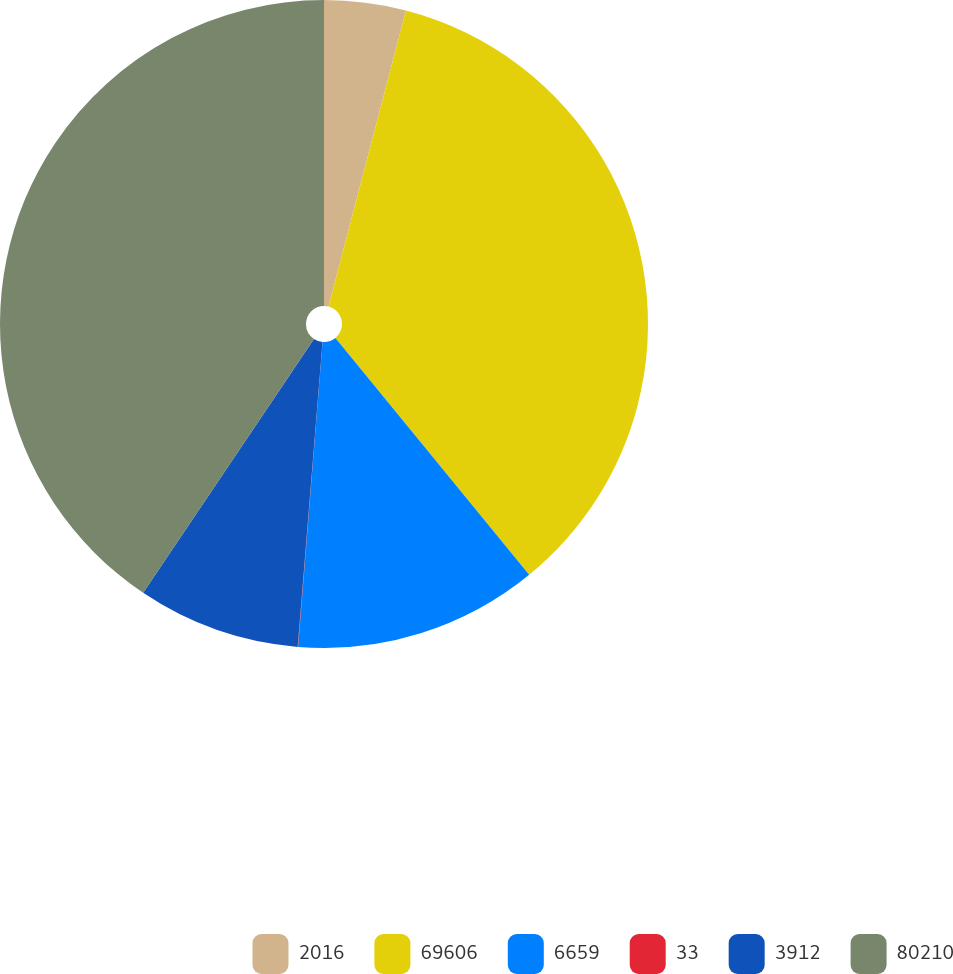Convert chart. <chart><loc_0><loc_0><loc_500><loc_500><pie_chart><fcel>2016<fcel>69606<fcel>6659<fcel>33<fcel>3912<fcel>80210<nl><fcel>4.07%<fcel>35.02%<fcel>12.19%<fcel>0.02%<fcel>8.13%<fcel>40.58%<nl></chart> 